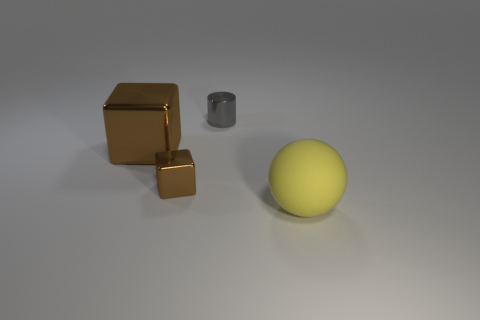Subtract all spheres. How many objects are left? 3 Add 1 shiny things. How many objects exist? 5 Subtract 2 brown cubes. How many objects are left? 2 Subtract 1 blocks. How many blocks are left? 1 Subtract all red cylinders. Subtract all yellow blocks. How many cylinders are left? 1 Subtract all tiny cyan rubber things. Subtract all cylinders. How many objects are left? 3 Add 4 small brown metal things. How many small brown metal things are left? 5 Add 4 cylinders. How many cylinders exist? 5 